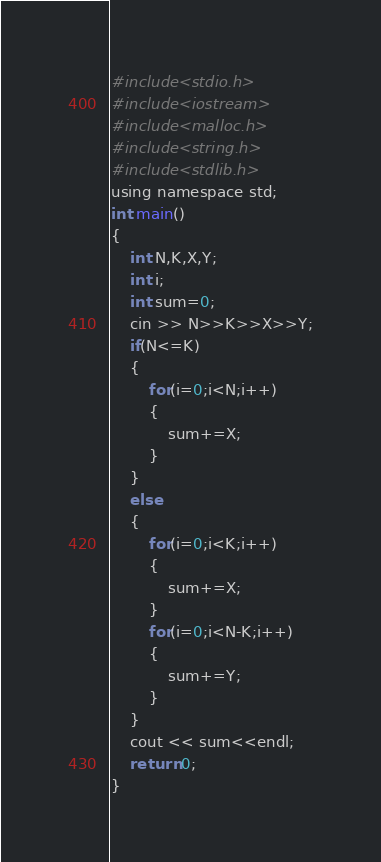Convert code to text. <code><loc_0><loc_0><loc_500><loc_500><_C_>#include<stdio.h>
#include<iostream>
#include<malloc.h>
#include<string.h>
#include<stdlib.h>
using namespace std;
int main()
{
	int N,K,X,Y;
	int i;
	int sum=0;
	cin >> N>>K>>X>>Y;
	if(N<=K)
	{
		for(i=0;i<N;i++)
		{
			sum+=X;
		}
	} 
	else
	{
		for(i=0;i<K;i++)
		{
			sum+=X;
		}
		for(i=0;i<N-K;i++)
		{
			sum+=Y;
		}
	}
	cout << sum<<endl;
	return 0;
}</code> 